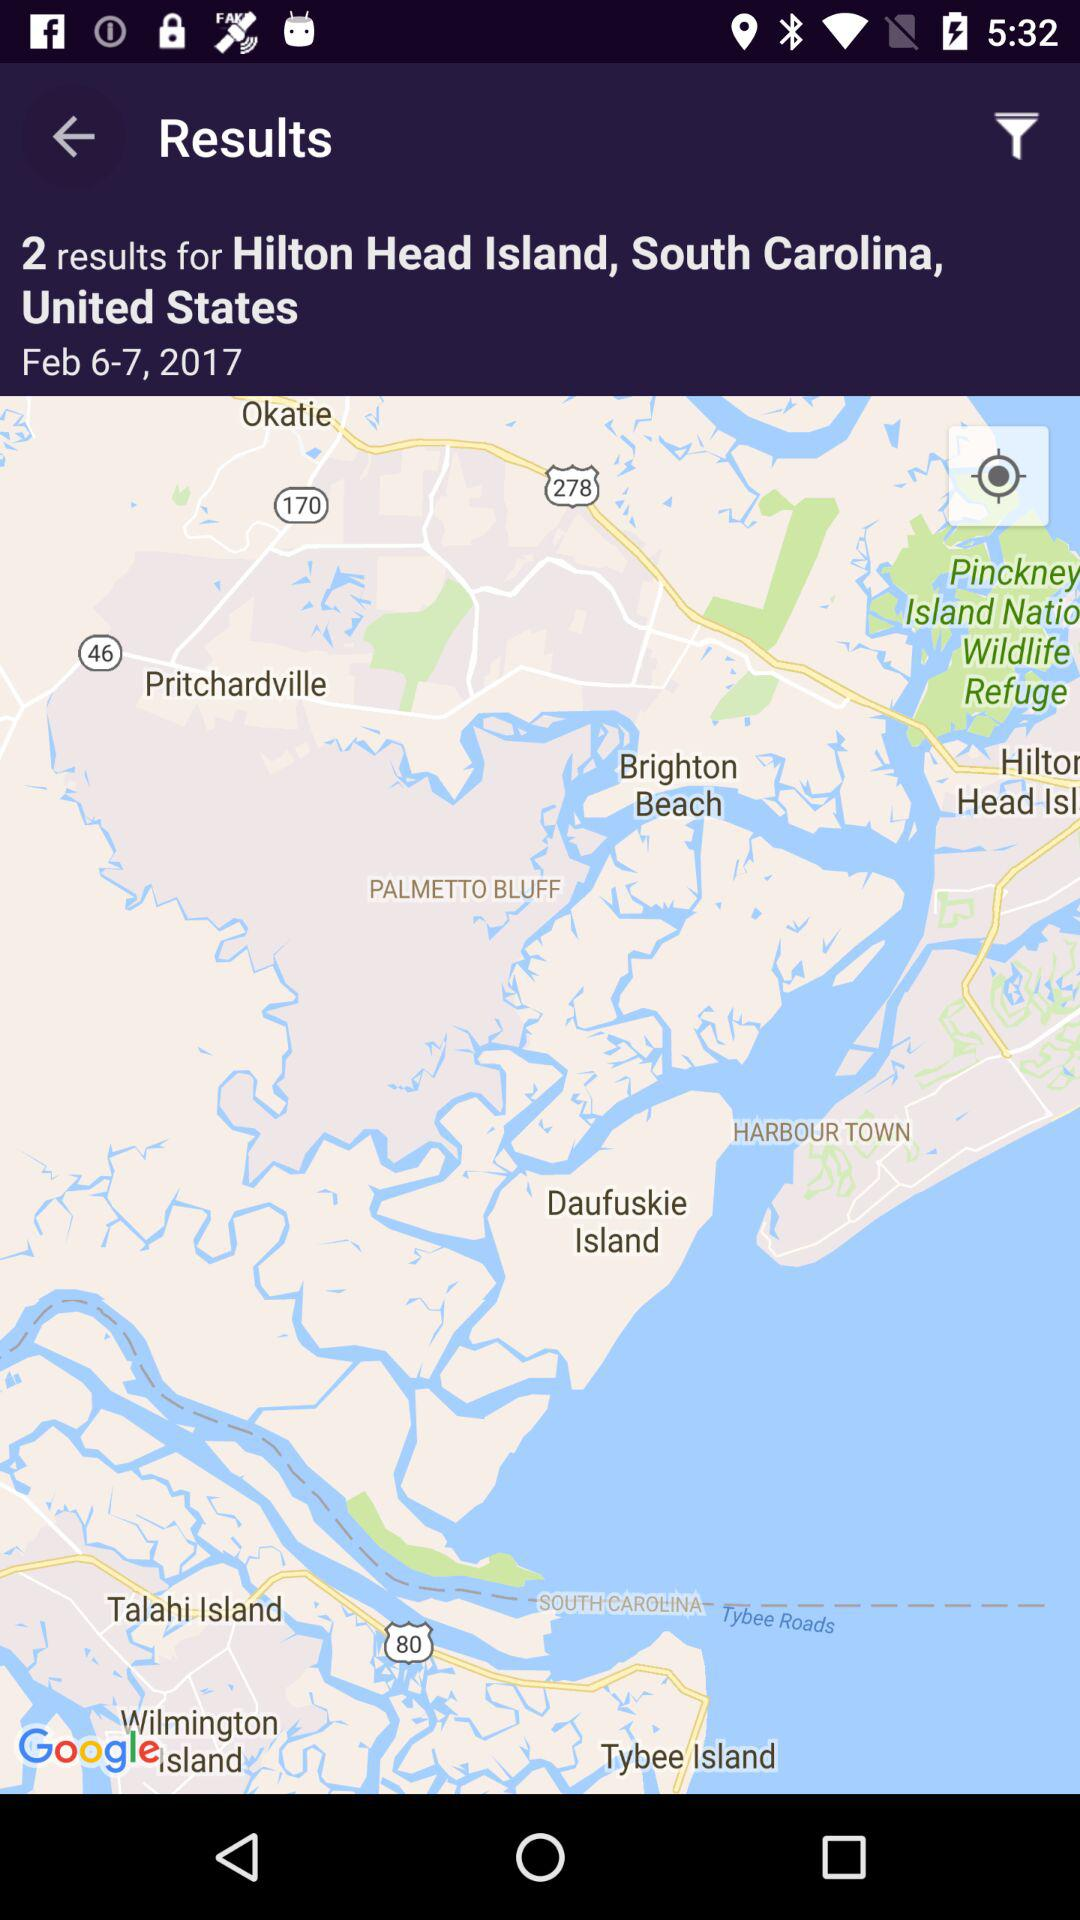What is the date range of the search results?
Answer the question using a single word or phrase. Feb 6-7, 2017 